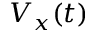Convert formula to latex. <formula><loc_0><loc_0><loc_500><loc_500>V _ { x } ( t )</formula> 